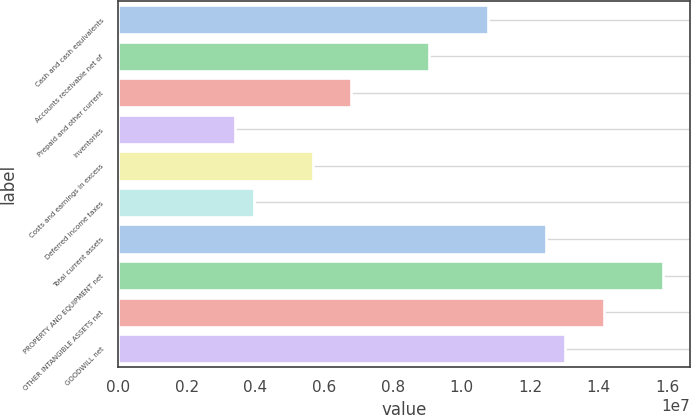Convert chart. <chart><loc_0><loc_0><loc_500><loc_500><bar_chart><fcel>Cash and cash equivalents<fcel>Accounts receivable net of<fcel>Prepaid and other current<fcel>Inventories<fcel>Costs and earnings in excess<fcel>Deferred income taxes<fcel>Total current assets<fcel>PROPERTY AND EQUIPMENT net<fcel>OTHER INTANGIBLE ASSETS net<fcel>GOODWILL net<nl><fcel>1.07582e+07<fcel>9.05951e+06<fcel>6.79464e+06<fcel>3.39733e+06<fcel>5.6622e+06<fcel>3.96355e+06<fcel>1.24568e+07<fcel>1.58541e+07<fcel>1.41555e+07<fcel>1.3023e+07<nl></chart> 